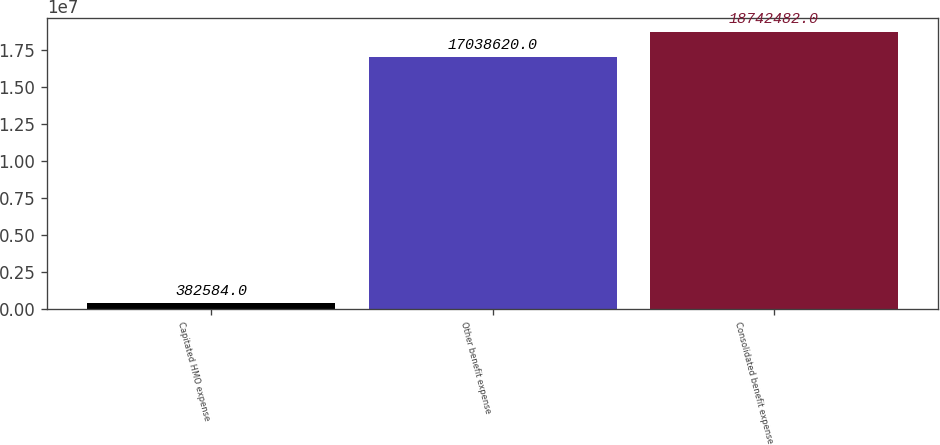<chart> <loc_0><loc_0><loc_500><loc_500><bar_chart><fcel>Capitated HMO expense<fcel>Other benefit expense<fcel>Consolidated benefit expense<nl><fcel>382584<fcel>1.70386e+07<fcel>1.87425e+07<nl></chart> 